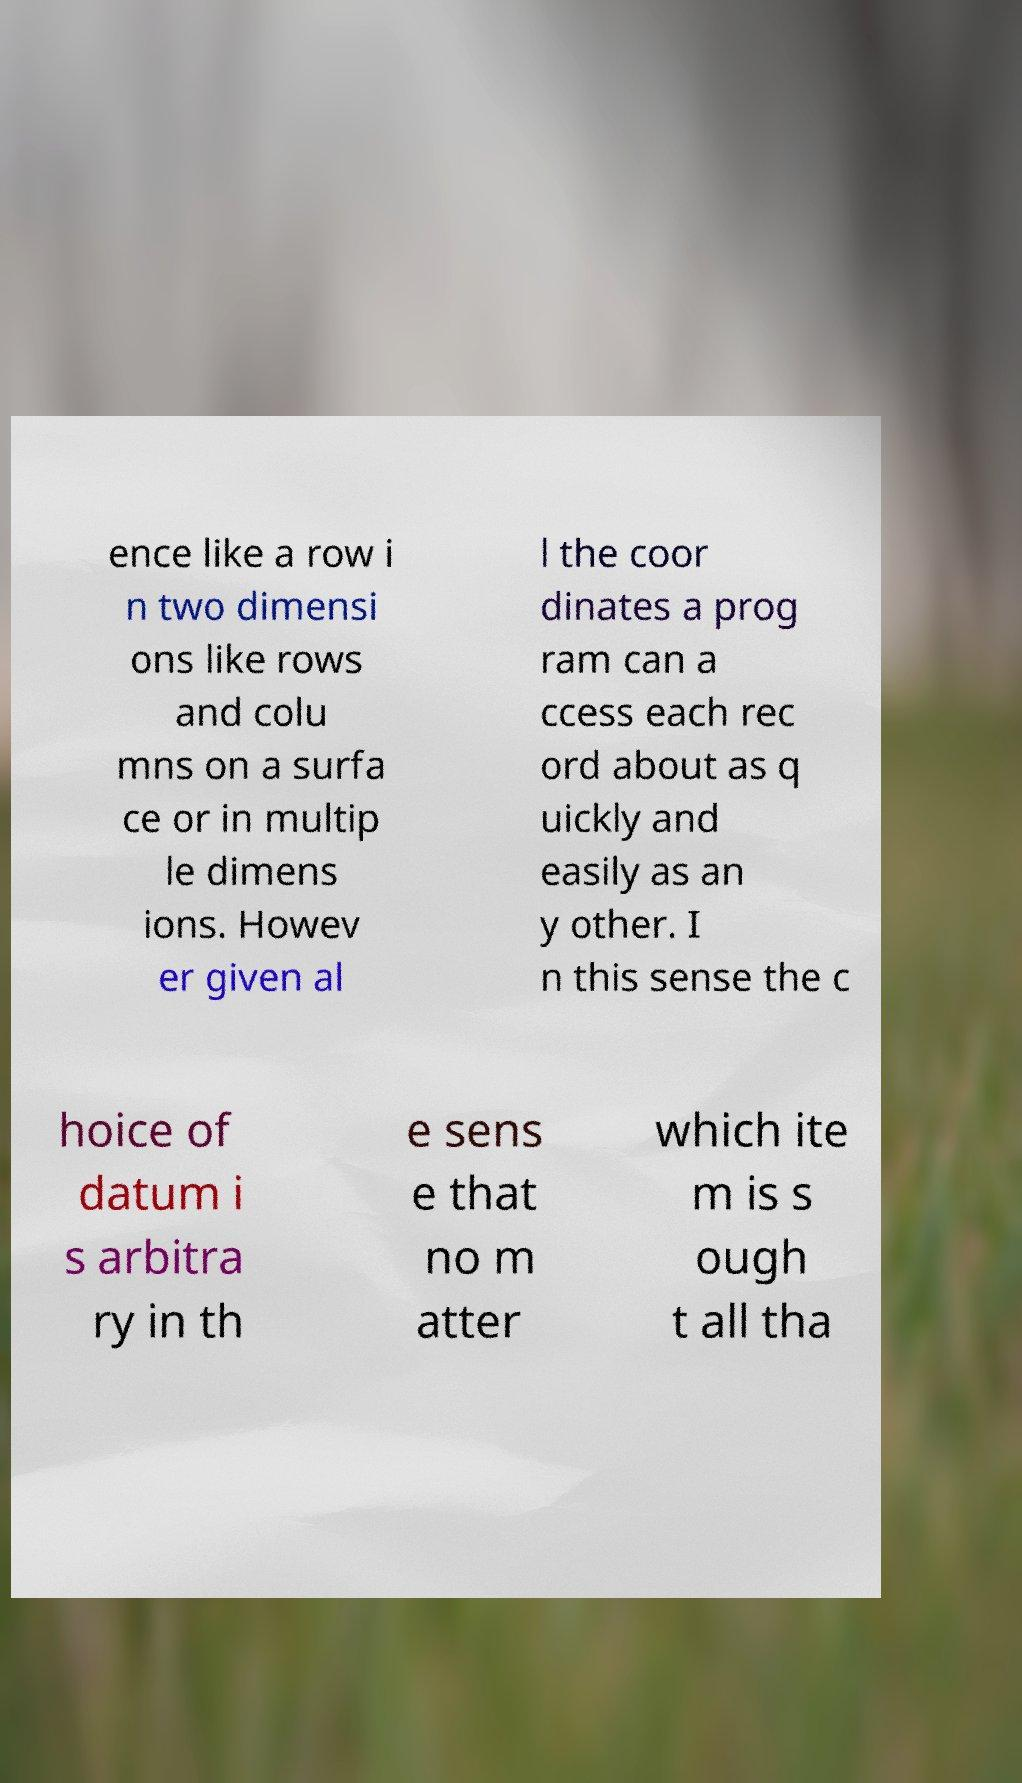Can you read and provide the text displayed in the image?This photo seems to have some interesting text. Can you extract and type it out for me? ence like a row i n two dimensi ons like rows and colu mns on a surfa ce or in multip le dimens ions. Howev er given al l the coor dinates a prog ram can a ccess each rec ord about as q uickly and easily as an y other. I n this sense the c hoice of datum i s arbitra ry in th e sens e that no m atter which ite m is s ough t all tha 